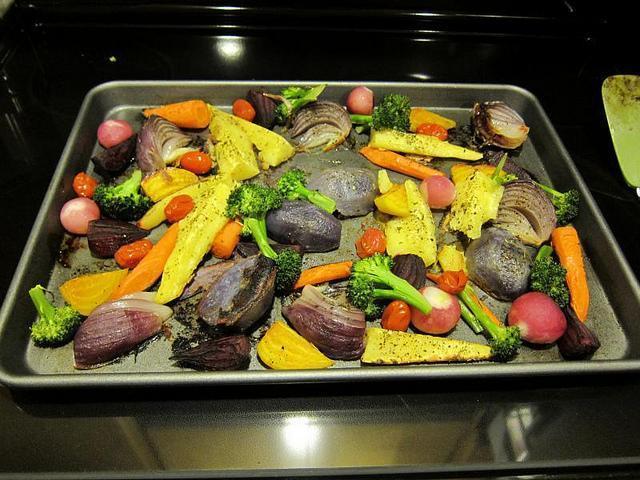How many pieces of mushroom are in this mix?
Give a very brief answer. 0. How many broccolis can you see?
Give a very brief answer. 2. 